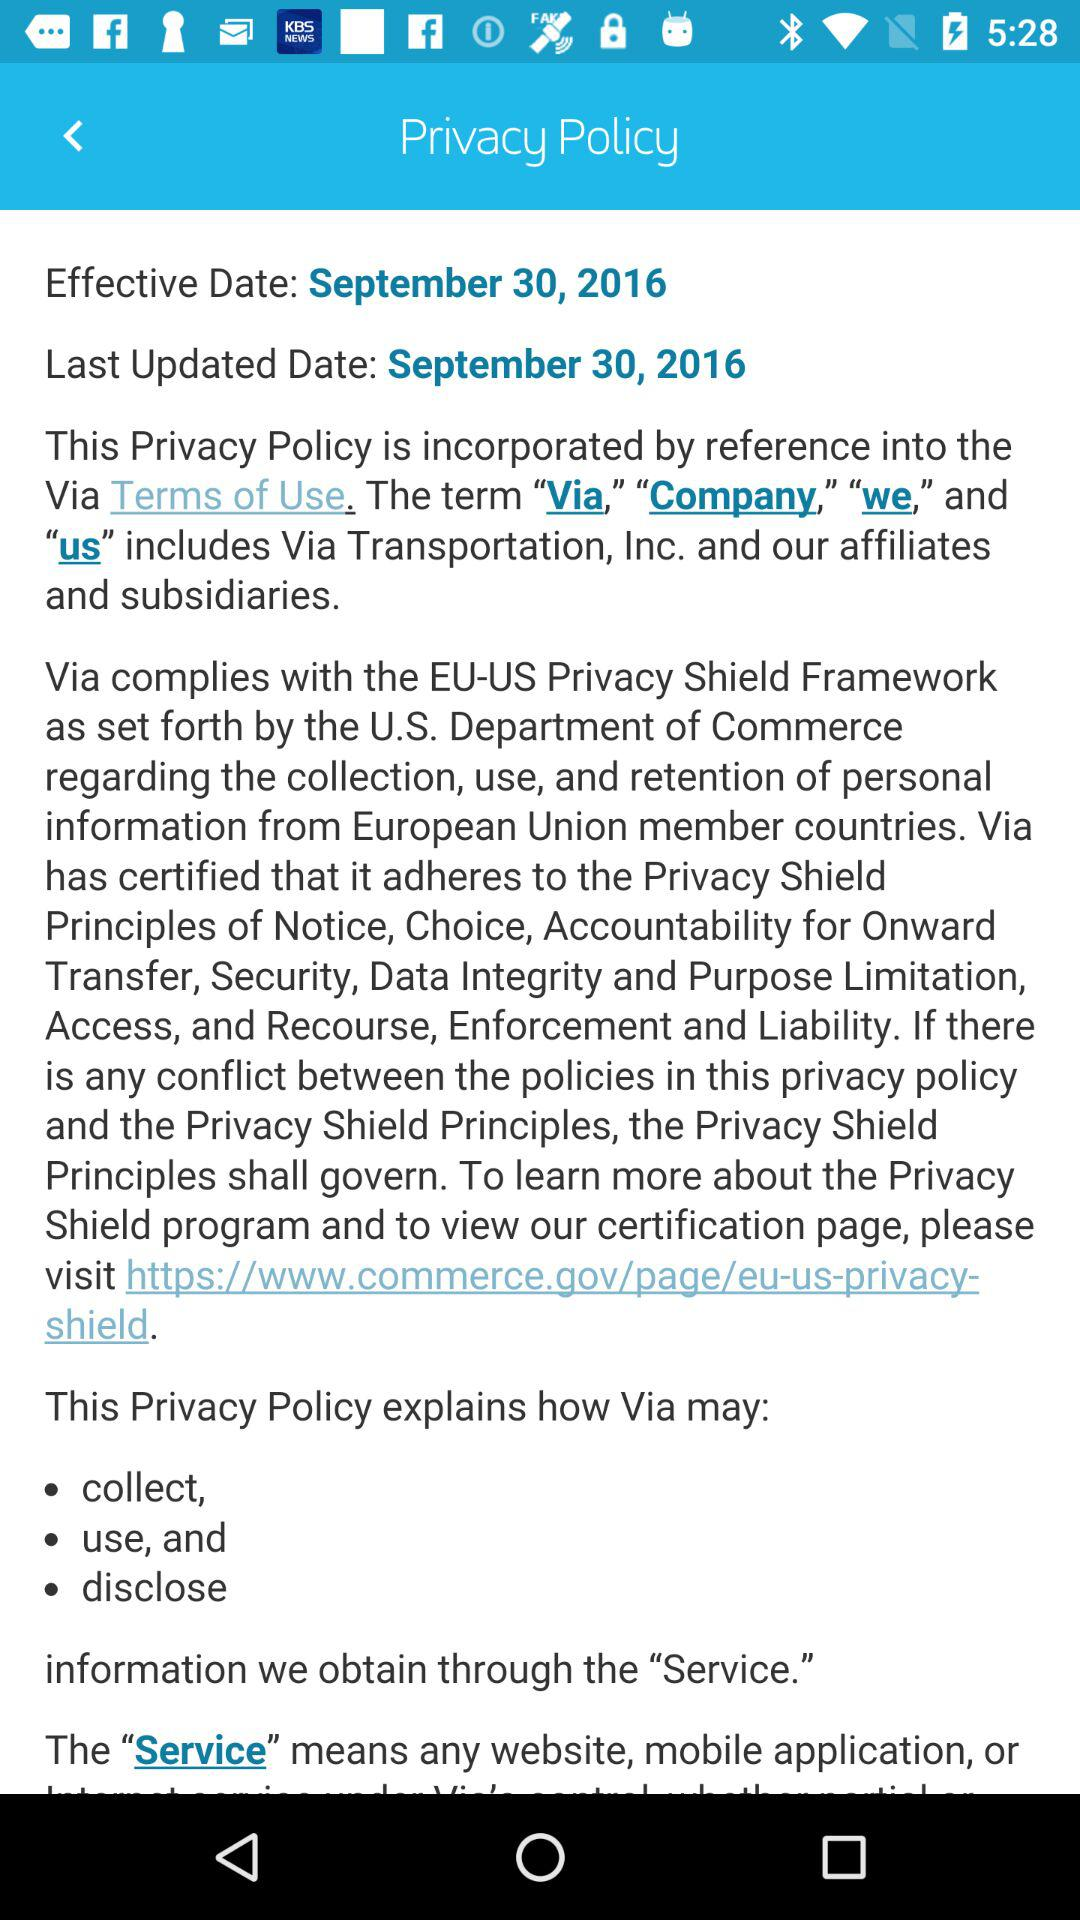When did the privacy policy become effective? The privacy policy became effective on September 30, 2016. 